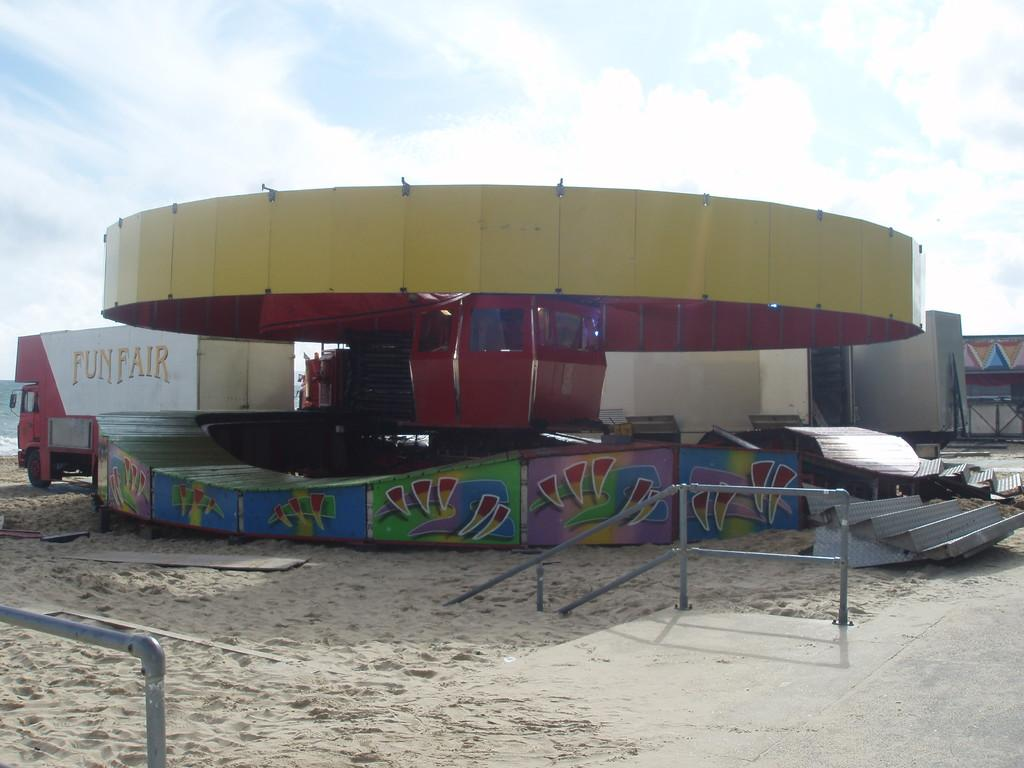What type of attraction is present in the image? There is a ride in the image. What is a feature that allows access to the ride? There is a staircase in the image. What type of barrier is present in the image? There is a fencing in the image. What type of terrain is visible in the image? There is sand in the image. What can be seen in the distance in the image? There is water visible in the background of the image. How would you describe the weather in the image? The sky is cloudy in the image. What type of disease is affecting the ride in the image? There is no indication of any disease affecting the ride in the image. How many houses are visible in the image? There are no houses present in the image. 